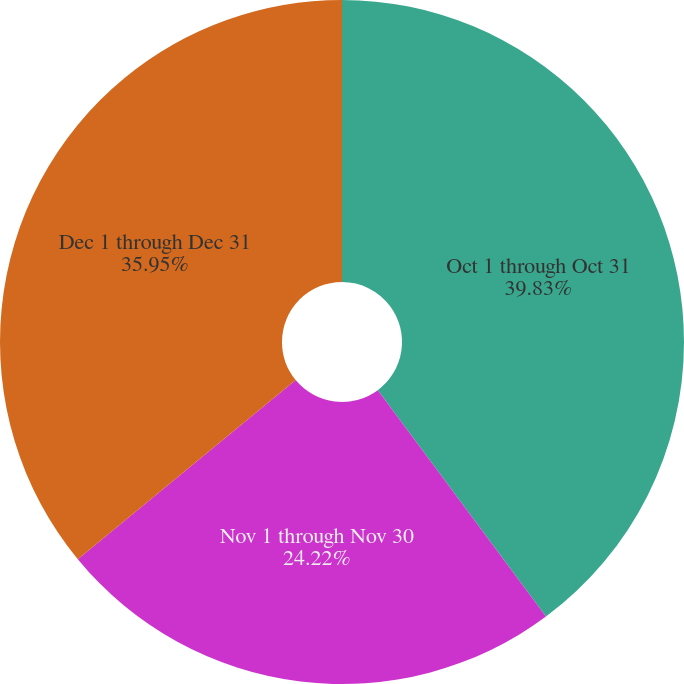Convert chart to OTSL. <chart><loc_0><loc_0><loc_500><loc_500><pie_chart><fcel>Oct 1 through Oct 31<fcel>Nov 1 through Nov 30<fcel>Dec 1 through Dec 31<nl><fcel>39.83%<fcel>24.22%<fcel>35.95%<nl></chart> 